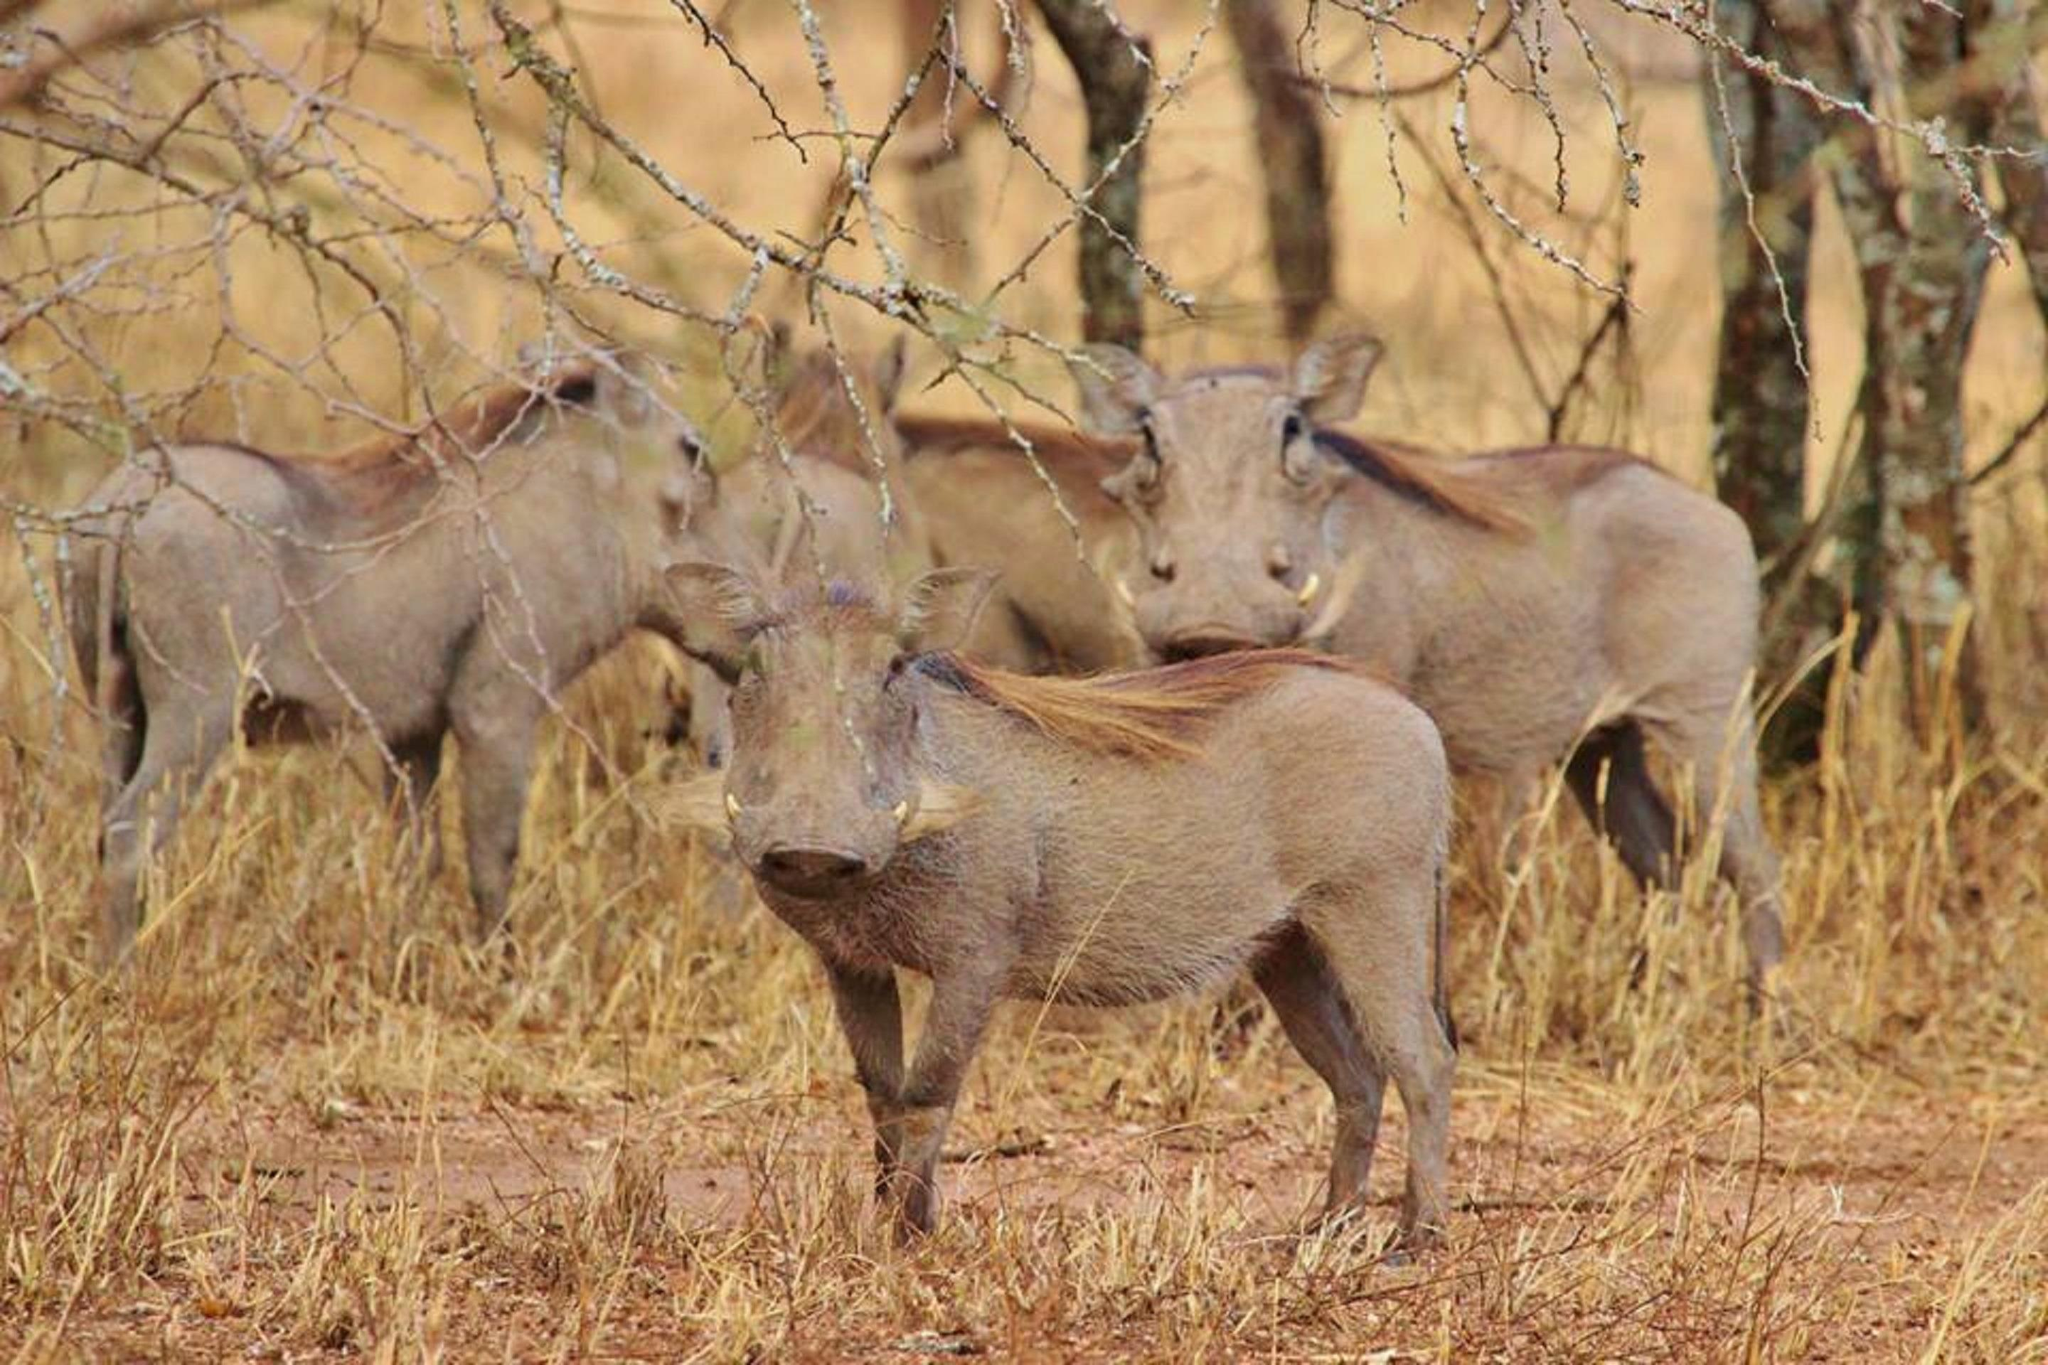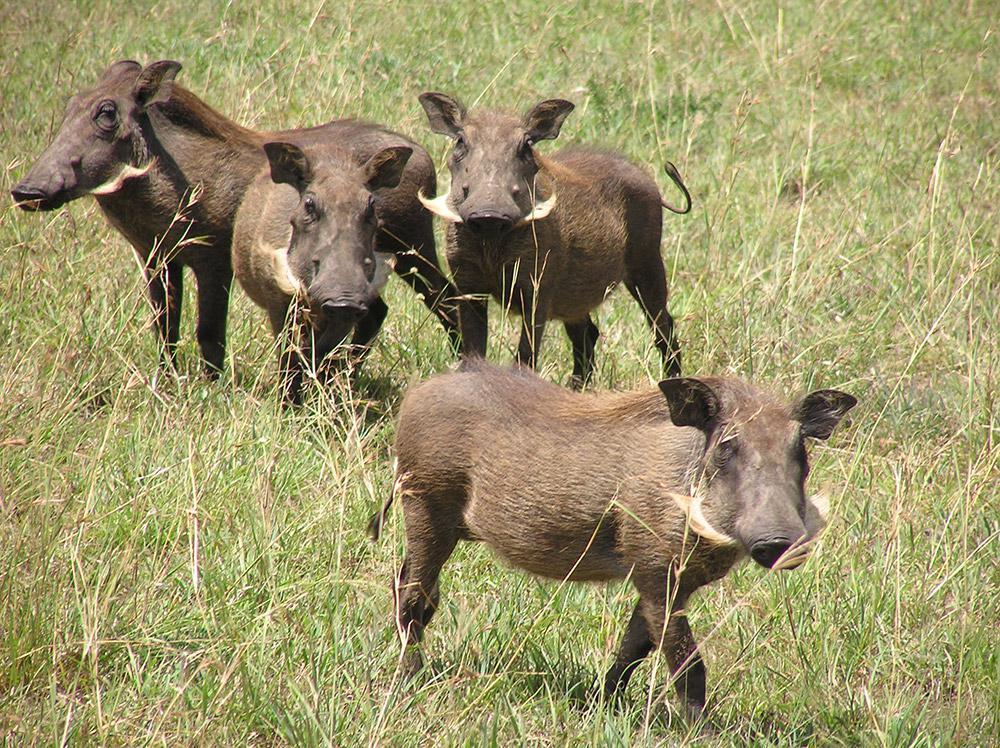The first image is the image on the left, the second image is the image on the right. Evaluate the accuracy of this statement regarding the images: "One of the images shows at least one adult boar with four or less babies.". Is it true? Answer yes or no. No. 